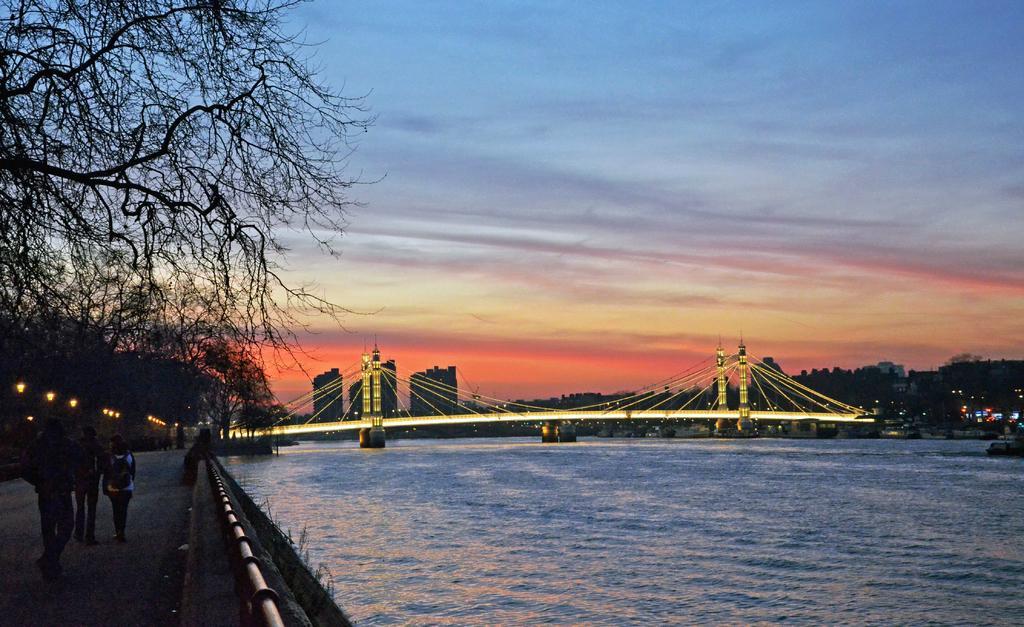Describe this image in one or two sentences. In this picture, we can see a few people, on the road, bridge with lights, water, trees, buildings, and the sky with clouds. 